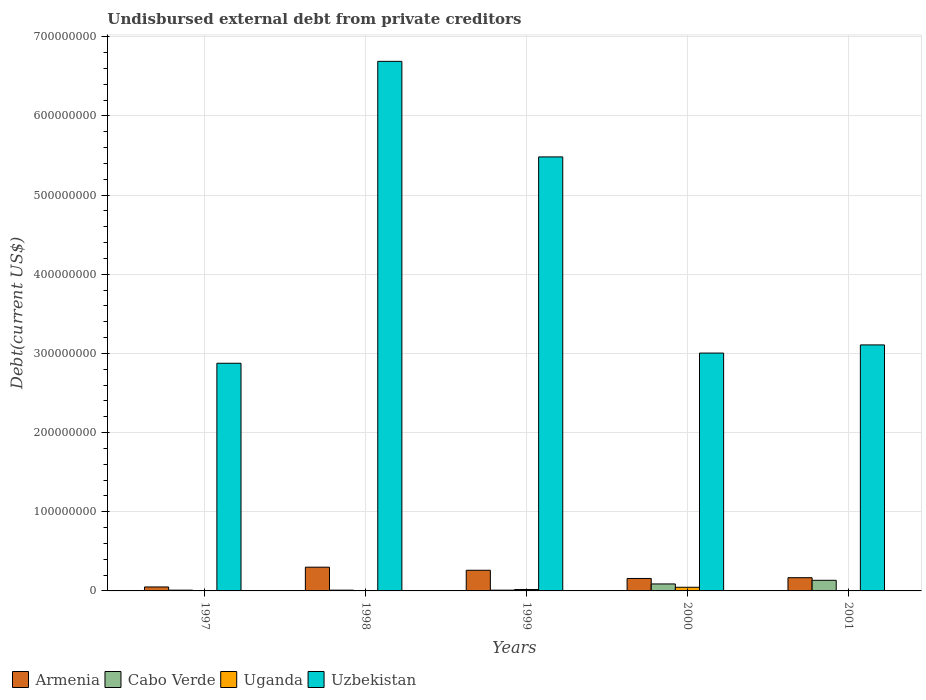How many different coloured bars are there?
Offer a very short reply. 4. How many groups of bars are there?
Provide a short and direct response. 5. How many bars are there on the 4th tick from the left?
Keep it short and to the point. 4. How many bars are there on the 2nd tick from the right?
Make the answer very short. 4. What is the total debt in Uzbekistan in 1997?
Offer a terse response. 2.88e+08. Across all years, what is the maximum total debt in Armenia?
Ensure brevity in your answer.  3.00e+07. Across all years, what is the minimum total debt in Armenia?
Your answer should be very brief. 5.00e+06. In which year was the total debt in Uzbekistan maximum?
Your response must be concise. 1998. In which year was the total debt in Uganda minimum?
Keep it short and to the point. 1998. What is the total total debt in Armenia in the graph?
Provide a succinct answer. 9.36e+07. What is the difference between the total debt in Armenia in 1998 and that in 2000?
Make the answer very short. 1.42e+07. What is the difference between the total debt in Uganda in 2000 and the total debt in Armenia in 1999?
Your response must be concise. -2.15e+07. What is the average total debt in Armenia per year?
Provide a short and direct response. 1.87e+07. In the year 2001, what is the difference between the total debt in Armenia and total debt in Cabo Verde?
Keep it short and to the point. 3.30e+06. In how many years, is the total debt in Armenia greater than 640000000 US$?
Your answer should be compact. 0. What is the ratio of the total debt in Cabo Verde in 1998 to that in 2000?
Keep it short and to the point. 0.11. Is the difference between the total debt in Armenia in 1998 and 2001 greater than the difference between the total debt in Cabo Verde in 1998 and 2001?
Your response must be concise. Yes. What is the difference between the highest and the second highest total debt in Uganda?
Your response must be concise. 2.85e+06. What is the difference between the highest and the lowest total debt in Uganda?
Give a very brief answer. 4.45e+06. In how many years, is the total debt in Uganda greater than the average total debt in Uganda taken over all years?
Your answer should be very brief. 2. What does the 2nd bar from the left in 2001 represents?
Provide a short and direct response. Cabo Verde. What does the 1st bar from the right in 2001 represents?
Provide a short and direct response. Uzbekistan. Are all the bars in the graph horizontal?
Offer a terse response. No. How many years are there in the graph?
Your answer should be very brief. 5. Are the values on the major ticks of Y-axis written in scientific E-notation?
Ensure brevity in your answer.  No. Does the graph contain grids?
Keep it short and to the point. Yes. How many legend labels are there?
Give a very brief answer. 4. What is the title of the graph?
Your response must be concise. Undisbursed external debt from private creditors. What is the label or title of the Y-axis?
Ensure brevity in your answer.  Debt(current US$). What is the Debt(current US$) of Cabo Verde in 1997?
Provide a short and direct response. 9.48e+05. What is the Debt(current US$) in Uganda in 1997?
Your answer should be compact. 1.96e+05. What is the Debt(current US$) of Uzbekistan in 1997?
Ensure brevity in your answer.  2.88e+08. What is the Debt(current US$) of Armenia in 1998?
Provide a short and direct response. 3.00e+07. What is the Debt(current US$) in Cabo Verde in 1998?
Your response must be concise. 9.48e+05. What is the Debt(current US$) of Uganda in 1998?
Your answer should be compact. 1.60e+05. What is the Debt(current US$) of Uzbekistan in 1998?
Make the answer very short. 6.69e+08. What is the Debt(current US$) in Armenia in 1999?
Ensure brevity in your answer.  2.61e+07. What is the Debt(current US$) in Cabo Verde in 1999?
Offer a terse response. 9.48e+05. What is the Debt(current US$) of Uganda in 1999?
Your answer should be very brief. 1.76e+06. What is the Debt(current US$) in Uzbekistan in 1999?
Give a very brief answer. 5.48e+08. What is the Debt(current US$) in Armenia in 2000?
Ensure brevity in your answer.  1.58e+07. What is the Debt(current US$) of Cabo Verde in 2000?
Your response must be concise. 8.81e+06. What is the Debt(current US$) of Uganda in 2000?
Your answer should be compact. 4.61e+06. What is the Debt(current US$) of Uzbekistan in 2000?
Your answer should be very brief. 3.00e+08. What is the Debt(current US$) of Armenia in 2001?
Offer a very short reply. 1.67e+07. What is the Debt(current US$) in Cabo Verde in 2001?
Make the answer very short. 1.34e+07. What is the Debt(current US$) of Uganda in 2001?
Your response must be concise. 3.35e+05. What is the Debt(current US$) in Uzbekistan in 2001?
Ensure brevity in your answer.  3.11e+08. Across all years, what is the maximum Debt(current US$) of Armenia?
Your answer should be very brief. 3.00e+07. Across all years, what is the maximum Debt(current US$) in Cabo Verde?
Offer a terse response. 1.34e+07. Across all years, what is the maximum Debt(current US$) in Uganda?
Make the answer very short. 4.61e+06. Across all years, what is the maximum Debt(current US$) in Uzbekistan?
Your response must be concise. 6.69e+08. Across all years, what is the minimum Debt(current US$) of Armenia?
Give a very brief answer. 5.00e+06. Across all years, what is the minimum Debt(current US$) in Cabo Verde?
Keep it short and to the point. 9.48e+05. Across all years, what is the minimum Debt(current US$) in Uganda?
Offer a terse response. 1.60e+05. Across all years, what is the minimum Debt(current US$) of Uzbekistan?
Provide a short and direct response. 2.88e+08. What is the total Debt(current US$) of Armenia in the graph?
Provide a short and direct response. 9.36e+07. What is the total Debt(current US$) of Cabo Verde in the graph?
Your response must be concise. 2.51e+07. What is the total Debt(current US$) in Uganda in the graph?
Offer a very short reply. 7.07e+06. What is the total Debt(current US$) of Uzbekistan in the graph?
Provide a short and direct response. 2.12e+09. What is the difference between the Debt(current US$) of Armenia in 1997 and that in 1998?
Keep it short and to the point. -2.50e+07. What is the difference between the Debt(current US$) in Uganda in 1997 and that in 1998?
Keep it short and to the point. 3.60e+04. What is the difference between the Debt(current US$) in Uzbekistan in 1997 and that in 1998?
Your response must be concise. -3.81e+08. What is the difference between the Debt(current US$) of Armenia in 1997 and that in 1999?
Give a very brief answer. -2.11e+07. What is the difference between the Debt(current US$) in Cabo Verde in 1997 and that in 1999?
Ensure brevity in your answer.  0. What is the difference between the Debt(current US$) of Uganda in 1997 and that in 1999?
Offer a very short reply. -1.57e+06. What is the difference between the Debt(current US$) in Uzbekistan in 1997 and that in 1999?
Your answer should be very brief. -2.61e+08. What is the difference between the Debt(current US$) of Armenia in 1997 and that in 2000?
Provide a short and direct response. -1.08e+07. What is the difference between the Debt(current US$) of Cabo Verde in 1997 and that in 2000?
Make the answer very short. -7.86e+06. What is the difference between the Debt(current US$) of Uganda in 1997 and that in 2000?
Keep it short and to the point. -4.42e+06. What is the difference between the Debt(current US$) of Uzbekistan in 1997 and that in 2000?
Provide a succinct answer. -1.29e+07. What is the difference between the Debt(current US$) of Armenia in 1997 and that in 2001?
Offer a very short reply. -1.17e+07. What is the difference between the Debt(current US$) of Cabo Verde in 1997 and that in 2001?
Make the answer very short. -1.25e+07. What is the difference between the Debt(current US$) in Uganda in 1997 and that in 2001?
Provide a succinct answer. -1.39e+05. What is the difference between the Debt(current US$) in Uzbekistan in 1997 and that in 2001?
Provide a succinct answer. -2.32e+07. What is the difference between the Debt(current US$) of Armenia in 1998 and that in 1999?
Provide a short and direct response. 3.90e+06. What is the difference between the Debt(current US$) in Cabo Verde in 1998 and that in 1999?
Your answer should be compact. 0. What is the difference between the Debt(current US$) of Uganda in 1998 and that in 1999?
Offer a terse response. -1.60e+06. What is the difference between the Debt(current US$) in Uzbekistan in 1998 and that in 1999?
Give a very brief answer. 1.21e+08. What is the difference between the Debt(current US$) in Armenia in 1998 and that in 2000?
Provide a succinct answer. 1.42e+07. What is the difference between the Debt(current US$) in Cabo Verde in 1998 and that in 2000?
Make the answer very short. -7.86e+06. What is the difference between the Debt(current US$) in Uganda in 1998 and that in 2000?
Your answer should be compact. -4.45e+06. What is the difference between the Debt(current US$) of Uzbekistan in 1998 and that in 2000?
Provide a short and direct response. 3.69e+08. What is the difference between the Debt(current US$) in Armenia in 1998 and that in 2001?
Your answer should be very brief. 1.33e+07. What is the difference between the Debt(current US$) in Cabo Verde in 1998 and that in 2001?
Provide a short and direct response. -1.25e+07. What is the difference between the Debt(current US$) in Uganda in 1998 and that in 2001?
Your response must be concise. -1.75e+05. What is the difference between the Debt(current US$) in Uzbekistan in 1998 and that in 2001?
Keep it short and to the point. 3.58e+08. What is the difference between the Debt(current US$) in Armenia in 1999 and that in 2000?
Offer a terse response. 1.04e+07. What is the difference between the Debt(current US$) of Cabo Verde in 1999 and that in 2000?
Ensure brevity in your answer.  -7.86e+06. What is the difference between the Debt(current US$) of Uganda in 1999 and that in 2000?
Offer a very short reply. -2.85e+06. What is the difference between the Debt(current US$) in Uzbekistan in 1999 and that in 2000?
Your response must be concise. 2.48e+08. What is the difference between the Debt(current US$) in Armenia in 1999 and that in 2001?
Your answer should be compact. 9.39e+06. What is the difference between the Debt(current US$) in Cabo Verde in 1999 and that in 2001?
Your answer should be very brief. -1.25e+07. What is the difference between the Debt(current US$) in Uganda in 1999 and that in 2001?
Your answer should be compact. 1.43e+06. What is the difference between the Debt(current US$) in Uzbekistan in 1999 and that in 2001?
Your answer should be compact. 2.38e+08. What is the difference between the Debt(current US$) in Armenia in 2000 and that in 2001?
Your answer should be very brief. -9.60e+05. What is the difference between the Debt(current US$) in Cabo Verde in 2000 and that in 2001?
Offer a very short reply. -4.60e+06. What is the difference between the Debt(current US$) of Uganda in 2000 and that in 2001?
Your response must be concise. 4.28e+06. What is the difference between the Debt(current US$) of Uzbekistan in 2000 and that in 2001?
Keep it short and to the point. -1.03e+07. What is the difference between the Debt(current US$) in Armenia in 1997 and the Debt(current US$) in Cabo Verde in 1998?
Provide a succinct answer. 4.05e+06. What is the difference between the Debt(current US$) in Armenia in 1997 and the Debt(current US$) in Uganda in 1998?
Offer a terse response. 4.84e+06. What is the difference between the Debt(current US$) of Armenia in 1997 and the Debt(current US$) of Uzbekistan in 1998?
Give a very brief answer. -6.64e+08. What is the difference between the Debt(current US$) in Cabo Verde in 1997 and the Debt(current US$) in Uganda in 1998?
Provide a succinct answer. 7.88e+05. What is the difference between the Debt(current US$) in Cabo Verde in 1997 and the Debt(current US$) in Uzbekistan in 1998?
Keep it short and to the point. -6.68e+08. What is the difference between the Debt(current US$) of Uganda in 1997 and the Debt(current US$) of Uzbekistan in 1998?
Your response must be concise. -6.69e+08. What is the difference between the Debt(current US$) in Armenia in 1997 and the Debt(current US$) in Cabo Verde in 1999?
Your answer should be compact. 4.05e+06. What is the difference between the Debt(current US$) of Armenia in 1997 and the Debt(current US$) of Uganda in 1999?
Provide a succinct answer. 3.24e+06. What is the difference between the Debt(current US$) in Armenia in 1997 and the Debt(current US$) in Uzbekistan in 1999?
Offer a very short reply. -5.43e+08. What is the difference between the Debt(current US$) of Cabo Verde in 1997 and the Debt(current US$) of Uganda in 1999?
Your answer should be compact. -8.16e+05. What is the difference between the Debt(current US$) of Cabo Verde in 1997 and the Debt(current US$) of Uzbekistan in 1999?
Give a very brief answer. -5.47e+08. What is the difference between the Debt(current US$) of Uganda in 1997 and the Debt(current US$) of Uzbekistan in 1999?
Provide a short and direct response. -5.48e+08. What is the difference between the Debt(current US$) of Armenia in 1997 and the Debt(current US$) of Cabo Verde in 2000?
Offer a very short reply. -3.81e+06. What is the difference between the Debt(current US$) in Armenia in 1997 and the Debt(current US$) in Uganda in 2000?
Your answer should be very brief. 3.87e+05. What is the difference between the Debt(current US$) in Armenia in 1997 and the Debt(current US$) in Uzbekistan in 2000?
Your response must be concise. -2.95e+08. What is the difference between the Debt(current US$) of Cabo Verde in 1997 and the Debt(current US$) of Uganda in 2000?
Your response must be concise. -3.66e+06. What is the difference between the Debt(current US$) in Cabo Verde in 1997 and the Debt(current US$) in Uzbekistan in 2000?
Provide a succinct answer. -3.00e+08. What is the difference between the Debt(current US$) of Uganda in 1997 and the Debt(current US$) of Uzbekistan in 2000?
Make the answer very short. -3.00e+08. What is the difference between the Debt(current US$) in Armenia in 1997 and the Debt(current US$) in Cabo Verde in 2001?
Your answer should be very brief. -8.41e+06. What is the difference between the Debt(current US$) in Armenia in 1997 and the Debt(current US$) in Uganda in 2001?
Give a very brief answer. 4.66e+06. What is the difference between the Debt(current US$) in Armenia in 1997 and the Debt(current US$) in Uzbekistan in 2001?
Your response must be concise. -3.06e+08. What is the difference between the Debt(current US$) in Cabo Verde in 1997 and the Debt(current US$) in Uganda in 2001?
Your answer should be compact. 6.13e+05. What is the difference between the Debt(current US$) in Cabo Verde in 1997 and the Debt(current US$) in Uzbekistan in 2001?
Your answer should be compact. -3.10e+08. What is the difference between the Debt(current US$) of Uganda in 1997 and the Debt(current US$) of Uzbekistan in 2001?
Provide a succinct answer. -3.11e+08. What is the difference between the Debt(current US$) in Armenia in 1998 and the Debt(current US$) in Cabo Verde in 1999?
Keep it short and to the point. 2.91e+07. What is the difference between the Debt(current US$) in Armenia in 1998 and the Debt(current US$) in Uganda in 1999?
Make the answer very short. 2.82e+07. What is the difference between the Debt(current US$) in Armenia in 1998 and the Debt(current US$) in Uzbekistan in 1999?
Your response must be concise. -5.18e+08. What is the difference between the Debt(current US$) of Cabo Verde in 1998 and the Debt(current US$) of Uganda in 1999?
Provide a short and direct response. -8.16e+05. What is the difference between the Debt(current US$) of Cabo Verde in 1998 and the Debt(current US$) of Uzbekistan in 1999?
Give a very brief answer. -5.47e+08. What is the difference between the Debt(current US$) of Uganda in 1998 and the Debt(current US$) of Uzbekistan in 1999?
Give a very brief answer. -5.48e+08. What is the difference between the Debt(current US$) in Armenia in 1998 and the Debt(current US$) in Cabo Verde in 2000?
Provide a succinct answer. 2.12e+07. What is the difference between the Debt(current US$) of Armenia in 1998 and the Debt(current US$) of Uganda in 2000?
Keep it short and to the point. 2.54e+07. What is the difference between the Debt(current US$) in Armenia in 1998 and the Debt(current US$) in Uzbekistan in 2000?
Offer a very short reply. -2.70e+08. What is the difference between the Debt(current US$) of Cabo Verde in 1998 and the Debt(current US$) of Uganda in 2000?
Your answer should be very brief. -3.66e+06. What is the difference between the Debt(current US$) in Cabo Verde in 1998 and the Debt(current US$) in Uzbekistan in 2000?
Ensure brevity in your answer.  -3.00e+08. What is the difference between the Debt(current US$) in Uganda in 1998 and the Debt(current US$) in Uzbekistan in 2000?
Offer a very short reply. -3.00e+08. What is the difference between the Debt(current US$) in Armenia in 1998 and the Debt(current US$) in Cabo Verde in 2001?
Ensure brevity in your answer.  1.66e+07. What is the difference between the Debt(current US$) in Armenia in 1998 and the Debt(current US$) in Uganda in 2001?
Provide a succinct answer. 2.97e+07. What is the difference between the Debt(current US$) of Armenia in 1998 and the Debt(current US$) of Uzbekistan in 2001?
Provide a succinct answer. -2.81e+08. What is the difference between the Debt(current US$) of Cabo Verde in 1998 and the Debt(current US$) of Uganda in 2001?
Your response must be concise. 6.13e+05. What is the difference between the Debt(current US$) in Cabo Verde in 1998 and the Debt(current US$) in Uzbekistan in 2001?
Give a very brief answer. -3.10e+08. What is the difference between the Debt(current US$) in Uganda in 1998 and the Debt(current US$) in Uzbekistan in 2001?
Your answer should be compact. -3.11e+08. What is the difference between the Debt(current US$) in Armenia in 1999 and the Debt(current US$) in Cabo Verde in 2000?
Your response must be concise. 1.73e+07. What is the difference between the Debt(current US$) of Armenia in 1999 and the Debt(current US$) of Uganda in 2000?
Your answer should be very brief. 2.15e+07. What is the difference between the Debt(current US$) of Armenia in 1999 and the Debt(current US$) of Uzbekistan in 2000?
Provide a succinct answer. -2.74e+08. What is the difference between the Debt(current US$) of Cabo Verde in 1999 and the Debt(current US$) of Uganda in 2000?
Keep it short and to the point. -3.66e+06. What is the difference between the Debt(current US$) in Cabo Verde in 1999 and the Debt(current US$) in Uzbekistan in 2000?
Offer a terse response. -3.00e+08. What is the difference between the Debt(current US$) in Uganda in 1999 and the Debt(current US$) in Uzbekistan in 2000?
Your response must be concise. -2.99e+08. What is the difference between the Debt(current US$) of Armenia in 1999 and the Debt(current US$) of Cabo Verde in 2001?
Give a very brief answer. 1.27e+07. What is the difference between the Debt(current US$) in Armenia in 1999 and the Debt(current US$) in Uganda in 2001?
Offer a terse response. 2.58e+07. What is the difference between the Debt(current US$) in Armenia in 1999 and the Debt(current US$) in Uzbekistan in 2001?
Your answer should be very brief. -2.85e+08. What is the difference between the Debt(current US$) in Cabo Verde in 1999 and the Debt(current US$) in Uganda in 2001?
Ensure brevity in your answer.  6.13e+05. What is the difference between the Debt(current US$) in Cabo Verde in 1999 and the Debt(current US$) in Uzbekistan in 2001?
Provide a succinct answer. -3.10e+08. What is the difference between the Debt(current US$) of Uganda in 1999 and the Debt(current US$) of Uzbekistan in 2001?
Offer a terse response. -3.09e+08. What is the difference between the Debt(current US$) of Armenia in 2000 and the Debt(current US$) of Cabo Verde in 2001?
Give a very brief answer. 2.34e+06. What is the difference between the Debt(current US$) of Armenia in 2000 and the Debt(current US$) of Uganda in 2001?
Offer a very short reply. 1.54e+07. What is the difference between the Debt(current US$) of Armenia in 2000 and the Debt(current US$) of Uzbekistan in 2001?
Make the answer very short. -2.95e+08. What is the difference between the Debt(current US$) of Cabo Verde in 2000 and the Debt(current US$) of Uganda in 2001?
Your answer should be compact. 8.48e+06. What is the difference between the Debt(current US$) in Cabo Verde in 2000 and the Debt(current US$) in Uzbekistan in 2001?
Keep it short and to the point. -3.02e+08. What is the difference between the Debt(current US$) in Uganda in 2000 and the Debt(current US$) in Uzbekistan in 2001?
Offer a very short reply. -3.06e+08. What is the average Debt(current US$) of Armenia per year?
Ensure brevity in your answer.  1.87e+07. What is the average Debt(current US$) in Cabo Verde per year?
Your answer should be very brief. 5.01e+06. What is the average Debt(current US$) of Uganda per year?
Provide a succinct answer. 1.41e+06. What is the average Debt(current US$) of Uzbekistan per year?
Provide a succinct answer. 4.23e+08. In the year 1997, what is the difference between the Debt(current US$) of Armenia and Debt(current US$) of Cabo Verde?
Your answer should be very brief. 4.05e+06. In the year 1997, what is the difference between the Debt(current US$) of Armenia and Debt(current US$) of Uganda?
Ensure brevity in your answer.  4.80e+06. In the year 1997, what is the difference between the Debt(current US$) in Armenia and Debt(current US$) in Uzbekistan?
Your response must be concise. -2.83e+08. In the year 1997, what is the difference between the Debt(current US$) of Cabo Verde and Debt(current US$) of Uganda?
Provide a succinct answer. 7.52e+05. In the year 1997, what is the difference between the Debt(current US$) in Cabo Verde and Debt(current US$) in Uzbekistan?
Give a very brief answer. -2.87e+08. In the year 1997, what is the difference between the Debt(current US$) in Uganda and Debt(current US$) in Uzbekistan?
Provide a succinct answer. -2.87e+08. In the year 1998, what is the difference between the Debt(current US$) of Armenia and Debt(current US$) of Cabo Verde?
Offer a very short reply. 2.91e+07. In the year 1998, what is the difference between the Debt(current US$) of Armenia and Debt(current US$) of Uganda?
Offer a terse response. 2.98e+07. In the year 1998, what is the difference between the Debt(current US$) of Armenia and Debt(current US$) of Uzbekistan?
Ensure brevity in your answer.  -6.39e+08. In the year 1998, what is the difference between the Debt(current US$) in Cabo Verde and Debt(current US$) in Uganda?
Offer a terse response. 7.88e+05. In the year 1998, what is the difference between the Debt(current US$) in Cabo Verde and Debt(current US$) in Uzbekistan?
Offer a very short reply. -6.68e+08. In the year 1998, what is the difference between the Debt(current US$) in Uganda and Debt(current US$) in Uzbekistan?
Keep it short and to the point. -6.69e+08. In the year 1999, what is the difference between the Debt(current US$) in Armenia and Debt(current US$) in Cabo Verde?
Your response must be concise. 2.52e+07. In the year 1999, what is the difference between the Debt(current US$) in Armenia and Debt(current US$) in Uganda?
Ensure brevity in your answer.  2.43e+07. In the year 1999, what is the difference between the Debt(current US$) of Armenia and Debt(current US$) of Uzbekistan?
Offer a very short reply. -5.22e+08. In the year 1999, what is the difference between the Debt(current US$) in Cabo Verde and Debt(current US$) in Uganda?
Offer a very short reply. -8.16e+05. In the year 1999, what is the difference between the Debt(current US$) of Cabo Verde and Debt(current US$) of Uzbekistan?
Provide a short and direct response. -5.47e+08. In the year 1999, what is the difference between the Debt(current US$) in Uganda and Debt(current US$) in Uzbekistan?
Keep it short and to the point. -5.47e+08. In the year 2000, what is the difference between the Debt(current US$) of Armenia and Debt(current US$) of Cabo Verde?
Your response must be concise. 6.94e+06. In the year 2000, what is the difference between the Debt(current US$) in Armenia and Debt(current US$) in Uganda?
Provide a succinct answer. 1.11e+07. In the year 2000, what is the difference between the Debt(current US$) in Armenia and Debt(current US$) in Uzbekistan?
Make the answer very short. -2.85e+08. In the year 2000, what is the difference between the Debt(current US$) of Cabo Verde and Debt(current US$) of Uganda?
Provide a succinct answer. 4.20e+06. In the year 2000, what is the difference between the Debt(current US$) of Cabo Verde and Debt(current US$) of Uzbekistan?
Offer a terse response. -2.92e+08. In the year 2000, what is the difference between the Debt(current US$) in Uganda and Debt(current US$) in Uzbekistan?
Ensure brevity in your answer.  -2.96e+08. In the year 2001, what is the difference between the Debt(current US$) of Armenia and Debt(current US$) of Cabo Verde?
Offer a very short reply. 3.30e+06. In the year 2001, what is the difference between the Debt(current US$) in Armenia and Debt(current US$) in Uganda?
Offer a very short reply. 1.64e+07. In the year 2001, what is the difference between the Debt(current US$) of Armenia and Debt(current US$) of Uzbekistan?
Offer a terse response. -2.94e+08. In the year 2001, what is the difference between the Debt(current US$) of Cabo Verde and Debt(current US$) of Uganda?
Your answer should be compact. 1.31e+07. In the year 2001, what is the difference between the Debt(current US$) of Cabo Verde and Debt(current US$) of Uzbekistan?
Your answer should be compact. -2.97e+08. In the year 2001, what is the difference between the Debt(current US$) of Uganda and Debt(current US$) of Uzbekistan?
Give a very brief answer. -3.10e+08. What is the ratio of the Debt(current US$) of Armenia in 1997 to that in 1998?
Offer a terse response. 0.17. What is the ratio of the Debt(current US$) in Uganda in 1997 to that in 1998?
Offer a very short reply. 1.23. What is the ratio of the Debt(current US$) of Uzbekistan in 1997 to that in 1998?
Your answer should be compact. 0.43. What is the ratio of the Debt(current US$) of Armenia in 1997 to that in 1999?
Provide a succinct answer. 0.19. What is the ratio of the Debt(current US$) in Cabo Verde in 1997 to that in 1999?
Ensure brevity in your answer.  1. What is the ratio of the Debt(current US$) in Uganda in 1997 to that in 1999?
Offer a terse response. 0.11. What is the ratio of the Debt(current US$) of Uzbekistan in 1997 to that in 1999?
Make the answer very short. 0.52. What is the ratio of the Debt(current US$) of Armenia in 1997 to that in 2000?
Your response must be concise. 0.32. What is the ratio of the Debt(current US$) in Cabo Verde in 1997 to that in 2000?
Ensure brevity in your answer.  0.11. What is the ratio of the Debt(current US$) of Uganda in 1997 to that in 2000?
Offer a terse response. 0.04. What is the ratio of the Debt(current US$) in Uzbekistan in 1997 to that in 2000?
Your answer should be very brief. 0.96. What is the ratio of the Debt(current US$) in Armenia in 1997 to that in 2001?
Ensure brevity in your answer.  0.3. What is the ratio of the Debt(current US$) of Cabo Verde in 1997 to that in 2001?
Provide a succinct answer. 0.07. What is the ratio of the Debt(current US$) in Uganda in 1997 to that in 2001?
Ensure brevity in your answer.  0.59. What is the ratio of the Debt(current US$) in Uzbekistan in 1997 to that in 2001?
Your response must be concise. 0.93. What is the ratio of the Debt(current US$) of Armenia in 1998 to that in 1999?
Give a very brief answer. 1.15. What is the ratio of the Debt(current US$) in Uganda in 1998 to that in 1999?
Offer a terse response. 0.09. What is the ratio of the Debt(current US$) in Uzbekistan in 1998 to that in 1999?
Offer a very short reply. 1.22. What is the ratio of the Debt(current US$) in Armenia in 1998 to that in 2000?
Provide a succinct answer. 1.9. What is the ratio of the Debt(current US$) of Cabo Verde in 1998 to that in 2000?
Offer a very short reply. 0.11. What is the ratio of the Debt(current US$) in Uganda in 1998 to that in 2000?
Make the answer very short. 0.03. What is the ratio of the Debt(current US$) in Uzbekistan in 1998 to that in 2000?
Ensure brevity in your answer.  2.23. What is the ratio of the Debt(current US$) in Armenia in 1998 to that in 2001?
Your answer should be very brief. 1.8. What is the ratio of the Debt(current US$) of Cabo Verde in 1998 to that in 2001?
Your answer should be very brief. 0.07. What is the ratio of the Debt(current US$) in Uganda in 1998 to that in 2001?
Give a very brief answer. 0.48. What is the ratio of the Debt(current US$) in Uzbekistan in 1998 to that in 2001?
Give a very brief answer. 2.15. What is the ratio of the Debt(current US$) of Armenia in 1999 to that in 2000?
Your answer should be compact. 1.66. What is the ratio of the Debt(current US$) in Cabo Verde in 1999 to that in 2000?
Ensure brevity in your answer.  0.11. What is the ratio of the Debt(current US$) in Uganda in 1999 to that in 2000?
Your answer should be very brief. 0.38. What is the ratio of the Debt(current US$) of Uzbekistan in 1999 to that in 2000?
Ensure brevity in your answer.  1.82. What is the ratio of the Debt(current US$) of Armenia in 1999 to that in 2001?
Provide a succinct answer. 1.56. What is the ratio of the Debt(current US$) in Cabo Verde in 1999 to that in 2001?
Keep it short and to the point. 0.07. What is the ratio of the Debt(current US$) of Uganda in 1999 to that in 2001?
Keep it short and to the point. 5.27. What is the ratio of the Debt(current US$) in Uzbekistan in 1999 to that in 2001?
Offer a terse response. 1.76. What is the ratio of the Debt(current US$) in Armenia in 2000 to that in 2001?
Your answer should be compact. 0.94. What is the ratio of the Debt(current US$) in Cabo Verde in 2000 to that in 2001?
Keep it short and to the point. 0.66. What is the ratio of the Debt(current US$) of Uganda in 2000 to that in 2001?
Your response must be concise. 13.77. What is the ratio of the Debt(current US$) in Uzbekistan in 2000 to that in 2001?
Make the answer very short. 0.97. What is the difference between the highest and the second highest Debt(current US$) in Armenia?
Give a very brief answer. 3.90e+06. What is the difference between the highest and the second highest Debt(current US$) in Cabo Verde?
Offer a very short reply. 4.60e+06. What is the difference between the highest and the second highest Debt(current US$) of Uganda?
Your answer should be compact. 2.85e+06. What is the difference between the highest and the second highest Debt(current US$) in Uzbekistan?
Ensure brevity in your answer.  1.21e+08. What is the difference between the highest and the lowest Debt(current US$) in Armenia?
Ensure brevity in your answer.  2.50e+07. What is the difference between the highest and the lowest Debt(current US$) in Cabo Verde?
Provide a short and direct response. 1.25e+07. What is the difference between the highest and the lowest Debt(current US$) of Uganda?
Give a very brief answer. 4.45e+06. What is the difference between the highest and the lowest Debt(current US$) of Uzbekistan?
Give a very brief answer. 3.81e+08. 